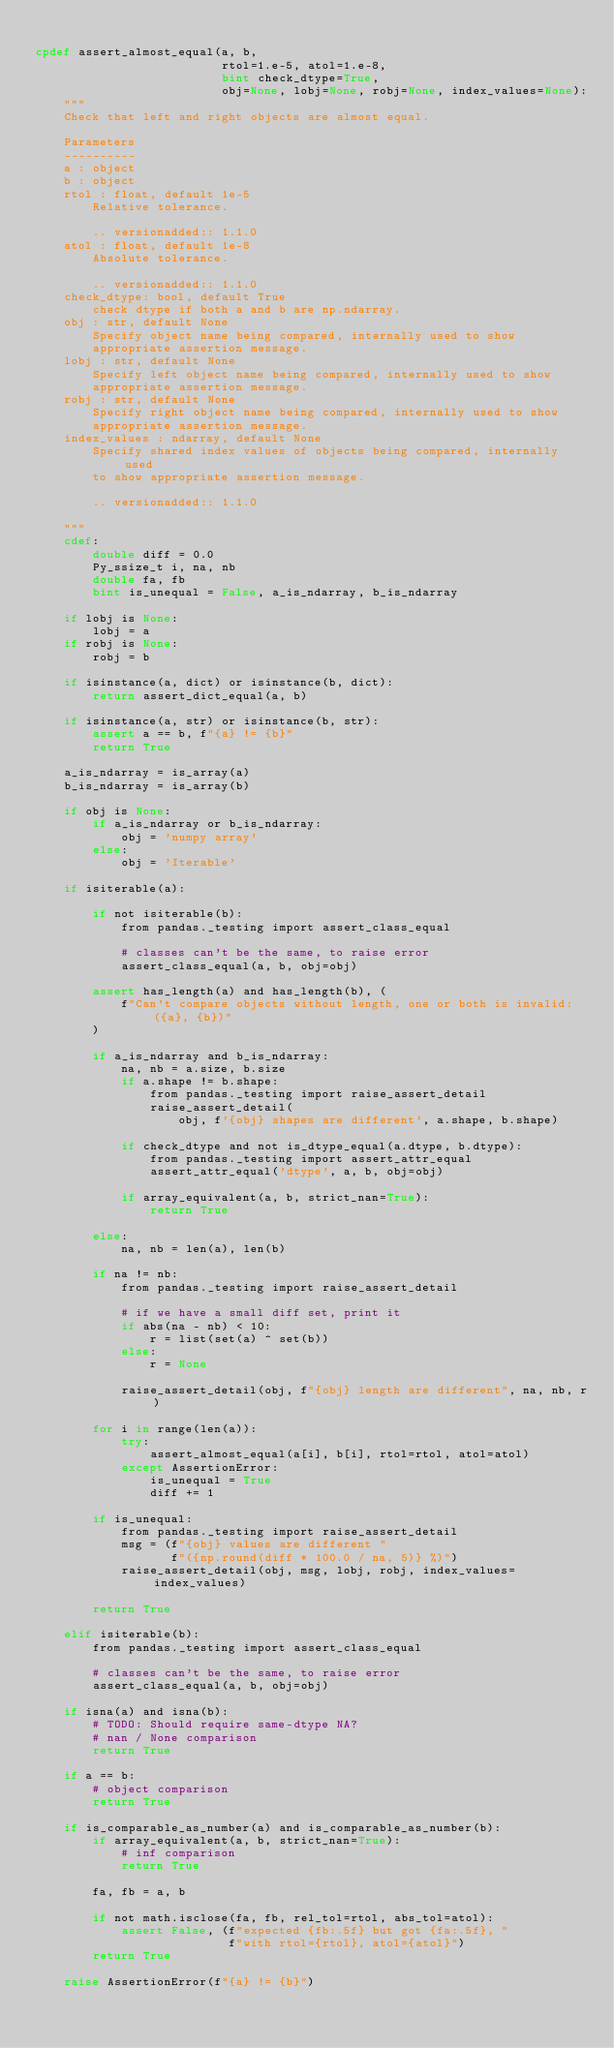<code> <loc_0><loc_0><loc_500><loc_500><_Cython_>
cpdef assert_almost_equal(a, b,
                          rtol=1.e-5, atol=1.e-8,
                          bint check_dtype=True,
                          obj=None, lobj=None, robj=None, index_values=None):
    """
    Check that left and right objects are almost equal.

    Parameters
    ----------
    a : object
    b : object
    rtol : float, default 1e-5
        Relative tolerance.

        .. versionadded:: 1.1.0
    atol : float, default 1e-8
        Absolute tolerance.

        .. versionadded:: 1.1.0
    check_dtype: bool, default True
        check dtype if both a and b are np.ndarray.
    obj : str, default None
        Specify object name being compared, internally used to show
        appropriate assertion message.
    lobj : str, default None
        Specify left object name being compared, internally used to show
        appropriate assertion message.
    robj : str, default None
        Specify right object name being compared, internally used to show
        appropriate assertion message.
    index_values : ndarray, default None
        Specify shared index values of objects being compared, internally used
        to show appropriate assertion message.

        .. versionadded:: 1.1.0

    """
    cdef:
        double diff = 0.0
        Py_ssize_t i, na, nb
        double fa, fb
        bint is_unequal = False, a_is_ndarray, b_is_ndarray

    if lobj is None:
        lobj = a
    if robj is None:
        robj = b

    if isinstance(a, dict) or isinstance(b, dict):
        return assert_dict_equal(a, b)

    if isinstance(a, str) or isinstance(b, str):
        assert a == b, f"{a} != {b}"
        return True

    a_is_ndarray = is_array(a)
    b_is_ndarray = is_array(b)

    if obj is None:
        if a_is_ndarray or b_is_ndarray:
            obj = 'numpy array'
        else:
            obj = 'Iterable'

    if isiterable(a):

        if not isiterable(b):
            from pandas._testing import assert_class_equal

            # classes can't be the same, to raise error
            assert_class_equal(a, b, obj=obj)

        assert has_length(a) and has_length(b), (
            f"Can't compare objects without length, one or both is invalid: ({a}, {b})"
        )

        if a_is_ndarray and b_is_ndarray:
            na, nb = a.size, b.size
            if a.shape != b.shape:
                from pandas._testing import raise_assert_detail
                raise_assert_detail(
                    obj, f'{obj} shapes are different', a.shape, b.shape)

            if check_dtype and not is_dtype_equal(a.dtype, b.dtype):
                from pandas._testing import assert_attr_equal
                assert_attr_equal('dtype', a, b, obj=obj)

            if array_equivalent(a, b, strict_nan=True):
                return True

        else:
            na, nb = len(a), len(b)

        if na != nb:
            from pandas._testing import raise_assert_detail

            # if we have a small diff set, print it
            if abs(na - nb) < 10:
                r = list(set(a) ^ set(b))
            else:
                r = None

            raise_assert_detail(obj, f"{obj} length are different", na, nb, r)

        for i in range(len(a)):
            try:
                assert_almost_equal(a[i], b[i], rtol=rtol, atol=atol)
            except AssertionError:
                is_unequal = True
                diff += 1

        if is_unequal:
            from pandas._testing import raise_assert_detail
            msg = (f"{obj} values are different "
                   f"({np.round(diff * 100.0 / na, 5)} %)")
            raise_assert_detail(obj, msg, lobj, robj, index_values=index_values)

        return True

    elif isiterable(b):
        from pandas._testing import assert_class_equal

        # classes can't be the same, to raise error
        assert_class_equal(a, b, obj=obj)

    if isna(a) and isna(b):
        # TODO: Should require same-dtype NA?
        # nan / None comparison
        return True

    if a == b:
        # object comparison
        return True

    if is_comparable_as_number(a) and is_comparable_as_number(b):
        if array_equivalent(a, b, strict_nan=True):
            # inf comparison
            return True

        fa, fb = a, b

        if not math.isclose(fa, fb, rel_tol=rtol, abs_tol=atol):
            assert False, (f"expected {fb:.5f} but got {fa:.5f}, "
                           f"with rtol={rtol}, atol={atol}")
        return True

    raise AssertionError(f"{a} != {b}")
</code> 